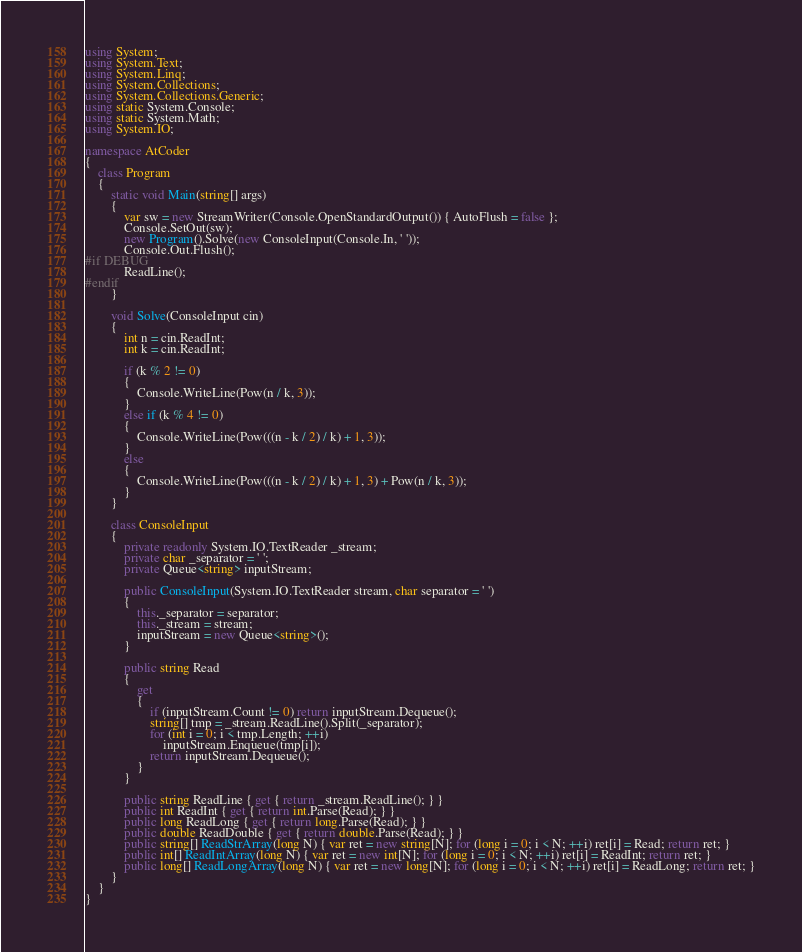Convert code to text. <code><loc_0><loc_0><loc_500><loc_500><_C#_>using System;
using System.Text;
using System.Linq;
using System.Collections;
using System.Collections.Generic;
using static System.Console;
using static System.Math;
using System.IO;

namespace AtCoder
{
    class Program
    {
        static void Main(string[] args)
        {
            var sw = new StreamWriter(Console.OpenStandardOutput()) { AutoFlush = false };
            Console.SetOut(sw);
            new Program().Solve(new ConsoleInput(Console.In, ' '));
            Console.Out.Flush();
#if DEBUG
            ReadLine();
#endif
        }

        void Solve(ConsoleInput cin)
        {
            int n = cin.ReadInt;
            int k = cin.ReadInt;

            if (k % 2 != 0)
            {
                Console.WriteLine(Pow(n / k, 3));
            }
            else if (k % 4 != 0)
            {
                Console.WriteLine(Pow(((n - k / 2) / k) + 1, 3));
            }
            else
            {
                Console.WriteLine(Pow(((n - k / 2) / k) + 1, 3) + Pow(n / k, 3));
            }
        }

        class ConsoleInput
        {
            private readonly System.IO.TextReader _stream;
            private char _separator = ' ';
            private Queue<string> inputStream;

            public ConsoleInput(System.IO.TextReader stream, char separator = ' ')
            {
                this._separator = separator;
                this._stream = stream;
                inputStream = new Queue<string>();
            }

            public string Read
            {
                get
                {
                    if (inputStream.Count != 0) return inputStream.Dequeue();
                    string[] tmp = _stream.ReadLine().Split(_separator);
                    for (int i = 0; i < tmp.Length; ++i)
                        inputStream.Enqueue(tmp[i]);
                    return inputStream.Dequeue();
                }
            }

            public string ReadLine { get { return _stream.ReadLine(); } }
            public int ReadInt { get { return int.Parse(Read); } }
            public long ReadLong { get { return long.Parse(Read); } }
            public double ReadDouble { get { return double.Parse(Read); } }
            public string[] ReadStrArray(long N) { var ret = new string[N]; for (long i = 0; i < N; ++i) ret[i] = Read; return ret; }
            public int[] ReadIntArray(long N) { var ret = new int[N]; for (long i = 0; i < N; ++i) ret[i] = ReadInt; return ret; }
            public long[] ReadLongArray(long N) { var ret = new long[N]; for (long i = 0; i < N; ++i) ret[i] = ReadLong; return ret; }
        }
    }
}</code> 